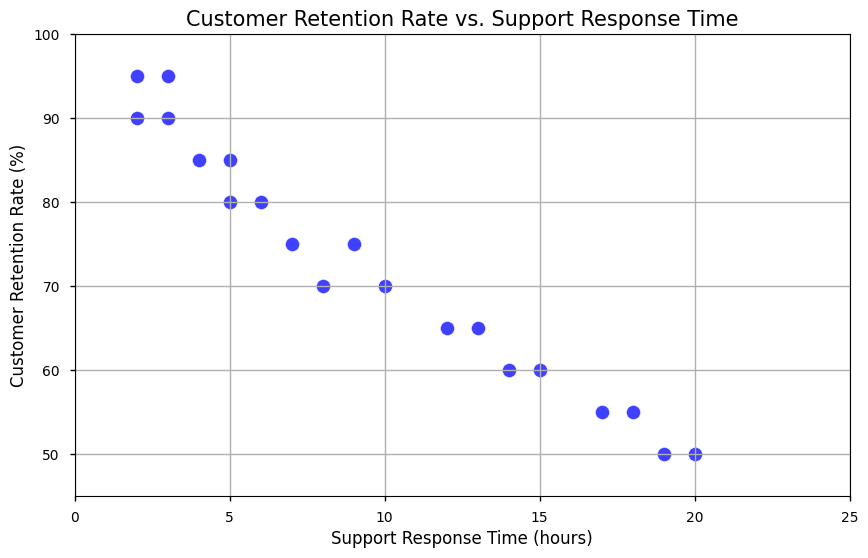What is the general relationship between customer retention rate and support response time in the scatter plot? From the scatter plot, there is a visible trend that shows as the support response time increases, the customer retention rate tends to decrease. This inverse relationship suggests that longer support response times might be correlated with lower customer retention rates.
Answer: Inverse relationship What is the customer retention rate when the support response time is 5 hours? From the scatter plot, there are two points where the support response time is 5 hours. The corresponding customer retention rates for these points are 85% and 80%.
Answer: 85% and 80% Which support response time has the highest customer retention rate? By observing the scatter plot, the highest customer retention rates are at 95%, and the corresponding support response times for these points are 2 and 3 hours.
Answer: 2 and 3 hours Compare the customer retention rate when the support response time is 10 hours and 15 hours. At 10 hours of support response time, the customer retention rate is 70%. At 15 hours, the customer retention rate is 60%. Both points reflect the decreasing trend in retention rate with increasing response time.
Answer: 70% (10 hours), 60% (15 hours) What is the average customer retention rate for support response times between 5 and 10 hours inclusive? Refer to the scatter plot data points where the support response times are within the 5 to 10 hours range. The points are (5,85), (5,80), (6,80), (7,75), (8,70), (9,75), and (10,70). Calculate the average retention rate: (85 + 80 + 80 + 75 + 70 + 75 + 70) / 7 = 535 / 7 ≈ 76.43
Answer: 76.43% Which data point has the longest support response time and what is the corresponding customer retention rate? The longest support response time value in the scatter plot is 20 hours. The corresponding customer retention rate for this support response time is 50%.
Answer: 50% (20 hours) Is there any support response time with more than one customer retention rate available, and what are they? In the scatter plot, the support response time of 5 hours is associated with two separate customer retention rates, which are 85% and 80%.
Answer: Yes, 85% and 80% (5 hours) What can be inferred if a company manages to reduce its support response time from 15 hours to 5 hours? By decreasing the support response time from 15 hours to 5 hours, the company could potentially increase its customer retention rate significantly. From the scatter plot, 15 hours is associated with a 60% retention rate, while 5 hours is associated with retention rates of 85% and 80%, indicating a leap of 20-25% in retention.
Answer: Potentially 85% or 80% What is the combined decrease in customer retention rate from a support response time of 2 hours to 20 hours? From the scatter plot, the customer retention rates for support response times of 2 hours and 20 hours are 95% and 50% respectively. Calculate the decrease in retention rate: 95% - 50% = 45%.
Answer: 45% When focusing on support response times of 3 hours and 12 hours, how much does the customer retention rate drop? The scatter plot shows that for a support response time of 3 hours, the retention rate is 90%, and for 12 hours, it is 65%. The drop in retention rate is calculated by subtracting the two: 90% - 65% = 25%.
Answer: 25% 